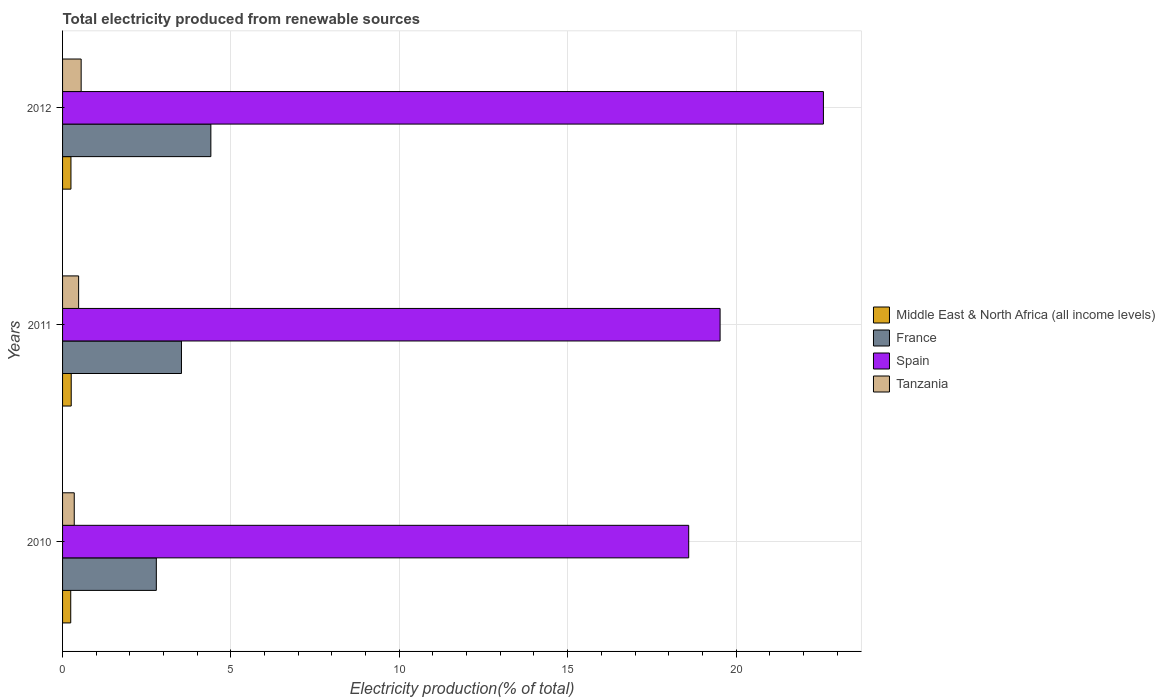How many bars are there on the 1st tick from the top?
Provide a succinct answer. 4. What is the label of the 2nd group of bars from the top?
Give a very brief answer. 2011. In how many cases, is the number of bars for a given year not equal to the number of legend labels?
Give a very brief answer. 0. What is the total electricity produced in Spain in 2011?
Ensure brevity in your answer.  19.53. Across all years, what is the maximum total electricity produced in France?
Your response must be concise. 4.4. Across all years, what is the minimum total electricity produced in Spain?
Offer a terse response. 18.59. What is the total total electricity produced in Middle East & North Africa (all income levels) in the graph?
Your answer should be very brief. 0.75. What is the difference between the total electricity produced in Tanzania in 2010 and that in 2012?
Your answer should be very brief. -0.21. What is the difference between the total electricity produced in Spain in 2010 and the total electricity produced in France in 2011?
Provide a succinct answer. 15.06. What is the average total electricity produced in Tanzania per year?
Make the answer very short. 0.46. In the year 2012, what is the difference between the total electricity produced in Spain and total electricity produced in Middle East & North Africa (all income levels)?
Provide a succinct answer. 22.35. What is the ratio of the total electricity produced in Tanzania in 2010 to that in 2011?
Your response must be concise. 0.73. Is the total electricity produced in Middle East & North Africa (all income levels) in 2010 less than that in 2011?
Keep it short and to the point. Yes. Is the difference between the total electricity produced in Spain in 2011 and 2012 greater than the difference between the total electricity produced in Middle East & North Africa (all income levels) in 2011 and 2012?
Your answer should be very brief. No. What is the difference between the highest and the second highest total electricity produced in Middle East & North Africa (all income levels)?
Offer a terse response. 0.01. What is the difference between the highest and the lowest total electricity produced in Tanzania?
Your response must be concise. 0.21. In how many years, is the total electricity produced in France greater than the average total electricity produced in France taken over all years?
Provide a succinct answer. 1. Is the sum of the total electricity produced in France in 2010 and 2012 greater than the maximum total electricity produced in Middle East & North Africa (all income levels) across all years?
Offer a very short reply. Yes. What does the 2nd bar from the top in 2010 represents?
Offer a terse response. Spain. What does the 3rd bar from the bottom in 2010 represents?
Give a very brief answer. Spain. How many bars are there?
Offer a very short reply. 12. How many years are there in the graph?
Your answer should be compact. 3. Are the values on the major ticks of X-axis written in scientific E-notation?
Offer a very short reply. No. Does the graph contain any zero values?
Provide a succinct answer. No. Where does the legend appear in the graph?
Keep it short and to the point. Center right. What is the title of the graph?
Your response must be concise. Total electricity produced from renewable sources. What is the label or title of the X-axis?
Your answer should be compact. Electricity production(% of total). What is the label or title of the Y-axis?
Offer a terse response. Years. What is the Electricity production(% of total) in Middle East & North Africa (all income levels) in 2010?
Offer a very short reply. 0.24. What is the Electricity production(% of total) of France in 2010?
Your response must be concise. 2.78. What is the Electricity production(% of total) in Spain in 2010?
Offer a very short reply. 18.59. What is the Electricity production(% of total) of Tanzania in 2010?
Offer a terse response. 0.35. What is the Electricity production(% of total) of Middle East & North Africa (all income levels) in 2011?
Offer a terse response. 0.26. What is the Electricity production(% of total) of France in 2011?
Ensure brevity in your answer.  3.53. What is the Electricity production(% of total) in Spain in 2011?
Keep it short and to the point. 19.53. What is the Electricity production(% of total) of Tanzania in 2011?
Offer a very short reply. 0.48. What is the Electricity production(% of total) of Middle East & North Africa (all income levels) in 2012?
Offer a terse response. 0.25. What is the Electricity production(% of total) in France in 2012?
Keep it short and to the point. 4.4. What is the Electricity production(% of total) in Spain in 2012?
Make the answer very short. 22.6. What is the Electricity production(% of total) in Tanzania in 2012?
Offer a terse response. 0.55. Across all years, what is the maximum Electricity production(% of total) in Middle East & North Africa (all income levels)?
Your answer should be compact. 0.26. Across all years, what is the maximum Electricity production(% of total) in France?
Ensure brevity in your answer.  4.4. Across all years, what is the maximum Electricity production(% of total) of Spain?
Your answer should be very brief. 22.6. Across all years, what is the maximum Electricity production(% of total) of Tanzania?
Your answer should be compact. 0.55. Across all years, what is the minimum Electricity production(% of total) of Middle East & North Africa (all income levels)?
Provide a short and direct response. 0.24. Across all years, what is the minimum Electricity production(% of total) in France?
Ensure brevity in your answer.  2.78. Across all years, what is the minimum Electricity production(% of total) in Spain?
Your response must be concise. 18.59. Across all years, what is the minimum Electricity production(% of total) of Tanzania?
Your answer should be compact. 0.35. What is the total Electricity production(% of total) in Middle East & North Africa (all income levels) in the graph?
Your response must be concise. 0.75. What is the total Electricity production(% of total) in France in the graph?
Make the answer very short. 10.72. What is the total Electricity production(% of total) of Spain in the graph?
Make the answer very short. 60.72. What is the total Electricity production(% of total) of Tanzania in the graph?
Your answer should be very brief. 1.38. What is the difference between the Electricity production(% of total) of Middle East & North Africa (all income levels) in 2010 and that in 2011?
Provide a short and direct response. -0.01. What is the difference between the Electricity production(% of total) in France in 2010 and that in 2011?
Offer a very short reply. -0.75. What is the difference between the Electricity production(% of total) in Spain in 2010 and that in 2011?
Make the answer very short. -0.93. What is the difference between the Electricity production(% of total) of Tanzania in 2010 and that in 2011?
Make the answer very short. -0.13. What is the difference between the Electricity production(% of total) of Middle East & North Africa (all income levels) in 2010 and that in 2012?
Your answer should be compact. -0.01. What is the difference between the Electricity production(% of total) in France in 2010 and that in 2012?
Keep it short and to the point. -1.62. What is the difference between the Electricity production(% of total) of Spain in 2010 and that in 2012?
Your answer should be very brief. -4. What is the difference between the Electricity production(% of total) of Tanzania in 2010 and that in 2012?
Your answer should be very brief. -0.21. What is the difference between the Electricity production(% of total) of Middle East & North Africa (all income levels) in 2011 and that in 2012?
Your answer should be compact. 0.01. What is the difference between the Electricity production(% of total) of France in 2011 and that in 2012?
Your response must be concise. -0.87. What is the difference between the Electricity production(% of total) in Spain in 2011 and that in 2012?
Your answer should be very brief. -3.07. What is the difference between the Electricity production(% of total) of Tanzania in 2011 and that in 2012?
Your answer should be compact. -0.08. What is the difference between the Electricity production(% of total) in Middle East & North Africa (all income levels) in 2010 and the Electricity production(% of total) in France in 2011?
Keep it short and to the point. -3.29. What is the difference between the Electricity production(% of total) of Middle East & North Africa (all income levels) in 2010 and the Electricity production(% of total) of Spain in 2011?
Offer a terse response. -19.28. What is the difference between the Electricity production(% of total) of Middle East & North Africa (all income levels) in 2010 and the Electricity production(% of total) of Tanzania in 2011?
Provide a short and direct response. -0.23. What is the difference between the Electricity production(% of total) of France in 2010 and the Electricity production(% of total) of Spain in 2011?
Your answer should be very brief. -16.74. What is the difference between the Electricity production(% of total) in France in 2010 and the Electricity production(% of total) in Tanzania in 2011?
Give a very brief answer. 2.31. What is the difference between the Electricity production(% of total) of Spain in 2010 and the Electricity production(% of total) of Tanzania in 2011?
Offer a very short reply. 18.12. What is the difference between the Electricity production(% of total) in Middle East & North Africa (all income levels) in 2010 and the Electricity production(% of total) in France in 2012?
Provide a short and direct response. -4.16. What is the difference between the Electricity production(% of total) in Middle East & North Africa (all income levels) in 2010 and the Electricity production(% of total) in Spain in 2012?
Keep it short and to the point. -22.35. What is the difference between the Electricity production(% of total) of Middle East & North Africa (all income levels) in 2010 and the Electricity production(% of total) of Tanzania in 2012?
Provide a succinct answer. -0.31. What is the difference between the Electricity production(% of total) of France in 2010 and the Electricity production(% of total) of Spain in 2012?
Make the answer very short. -19.81. What is the difference between the Electricity production(% of total) of France in 2010 and the Electricity production(% of total) of Tanzania in 2012?
Offer a terse response. 2.23. What is the difference between the Electricity production(% of total) of Spain in 2010 and the Electricity production(% of total) of Tanzania in 2012?
Your response must be concise. 18.04. What is the difference between the Electricity production(% of total) in Middle East & North Africa (all income levels) in 2011 and the Electricity production(% of total) in France in 2012?
Your answer should be very brief. -4.15. What is the difference between the Electricity production(% of total) of Middle East & North Africa (all income levels) in 2011 and the Electricity production(% of total) of Spain in 2012?
Make the answer very short. -22.34. What is the difference between the Electricity production(% of total) of Middle East & North Africa (all income levels) in 2011 and the Electricity production(% of total) of Tanzania in 2012?
Offer a terse response. -0.3. What is the difference between the Electricity production(% of total) of France in 2011 and the Electricity production(% of total) of Spain in 2012?
Your answer should be very brief. -19.06. What is the difference between the Electricity production(% of total) in France in 2011 and the Electricity production(% of total) in Tanzania in 2012?
Give a very brief answer. 2.98. What is the difference between the Electricity production(% of total) in Spain in 2011 and the Electricity production(% of total) in Tanzania in 2012?
Keep it short and to the point. 18.97. What is the average Electricity production(% of total) of Middle East & North Africa (all income levels) per year?
Your answer should be very brief. 0.25. What is the average Electricity production(% of total) of France per year?
Offer a terse response. 3.57. What is the average Electricity production(% of total) of Spain per year?
Provide a succinct answer. 20.24. What is the average Electricity production(% of total) of Tanzania per year?
Your response must be concise. 0.46. In the year 2010, what is the difference between the Electricity production(% of total) of Middle East & North Africa (all income levels) and Electricity production(% of total) of France?
Provide a succinct answer. -2.54. In the year 2010, what is the difference between the Electricity production(% of total) of Middle East & North Africa (all income levels) and Electricity production(% of total) of Spain?
Provide a succinct answer. -18.35. In the year 2010, what is the difference between the Electricity production(% of total) in Middle East & North Africa (all income levels) and Electricity production(% of total) in Tanzania?
Your response must be concise. -0.1. In the year 2010, what is the difference between the Electricity production(% of total) of France and Electricity production(% of total) of Spain?
Make the answer very short. -15.81. In the year 2010, what is the difference between the Electricity production(% of total) in France and Electricity production(% of total) in Tanzania?
Keep it short and to the point. 2.44. In the year 2010, what is the difference between the Electricity production(% of total) of Spain and Electricity production(% of total) of Tanzania?
Offer a terse response. 18.25. In the year 2011, what is the difference between the Electricity production(% of total) of Middle East & North Africa (all income levels) and Electricity production(% of total) of France?
Keep it short and to the point. -3.27. In the year 2011, what is the difference between the Electricity production(% of total) in Middle East & North Africa (all income levels) and Electricity production(% of total) in Spain?
Offer a very short reply. -19.27. In the year 2011, what is the difference between the Electricity production(% of total) of Middle East & North Africa (all income levels) and Electricity production(% of total) of Tanzania?
Make the answer very short. -0.22. In the year 2011, what is the difference between the Electricity production(% of total) of France and Electricity production(% of total) of Spain?
Offer a very short reply. -16. In the year 2011, what is the difference between the Electricity production(% of total) in France and Electricity production(% of total) in Tanzania?
Make the answer very short. 3.05. In the year 2011, what is the difference between the Electricity production(% of total) in Spain and Electricity production(% of total) in Tanzania?
Your answer should be very brief. 19.05. In the year 2012, what is the difference between the Electricity production(% of total) of Middle East & North Africa (all income levels) and Electricity production(% of total) of France?
Ensure brevity in your answer.  -4.16. In the year 2012, what is the difference between the Electricity production(% of total) in Middle East & North Africa (all income levels) and Electricity production(% of total) in Spain?
Your answer should be compact. -22.35. In the year 2012, what is the difference between the Electricity production(% of total) in Middle East & North Africa (all income levels) and Electricity production(% of total) in Tanzania?
Offer a terse response. -0.3. In the year 2012, what is the difference between the Electricity production(% of total) of France and Electricity production(% of total) of Spain?
Provide a short and direct response. -18.19. In the year 2012, what is the difference between the Electricity production(% of total) of France and Electricity production(% of total) of Tanzania?
Keep it short and to the point. 3.85. In the year 2012, what is the difference between the Electricity production(% of total) in Spain and Electricity production(% of total) in Tanzania?
Offer a very short reply. 22.04. What is the ratio of the Electricity production(% of total) of Middle East & North Africa (all income levels) in 2010 to that in 2011?
Ensure brevity in your answer.  0.94. What is the ratio of the Electricity production(% of total) of France in 2010 to that in 2011?
Your response must be concise. 0.79. What is the ratio of the Electricity production(% of total) in Spain in 2010 to that in 2011?
Your answer should be very brief. 0.95. What is the ratio of the Electricity production(% of total) of Tanzania in 2010 to that in 2011?
Provide a short and direct response. 0.73. What is the ratio of the Electricity production(% of total) of Middle East & North Africa (all income levels) in 2010 to that in 2012?
Ensure brevity in your answer.  0.98. What is the ratio of the Electricity production(% of total) in France in 2010 to that in 2012?
Offer a terse response. 0.63. What is the ratio of the Electricity production(% of total) in Spain in 2010 to that in 2012?
Your answer should be compact. 0.82. What is the ratio of the Electricity production(% of total) of Tanzania in 2010 to that in 2012?
Give a very brief answer. 0.63. What is the ratio of the Electricity production(% of total) in Middle East & North Africa (all income levels) in 2011 to that in 2012?
Keep it short and to the point. 1.03. What is the ratio of the Electricity production(% of total) in France in 2011 to that in 2012?
Offer a very short reply. 0.8. What is the ratio of the Electricity production(% of total) of Spain in 2011 to that in 2012?
Keep it short and to the point. 0.86. What is the ratio of the Electricity production(% of total) of Tanzania in 2011 to that in 2012?
Give a very brief answer. 0.86. What is the difference between the highest and the second highest Electricity production(% of total) in Middle East & North Africa (all income levels)?
Give a very brief answer. 0.01. What is the difference between the highest and the second highest Electricity production(% of total) in France?
Keep it short and to the point. 0.87. What is the difference between the highest and the second highest Electricity production(% of total) of Spain?
Make the answer very short. 3.07. What is the difference between the highest and the second highest Electricity production(% of total) of Tanzania?
Make the answer very short. 0.08. What is the difference between the highest and the lowest Electricity production(% of total) in Middle East & North Africa (all income levels)?
Your answer should be very brief. 0.01. What is the difference between the highest and the lowest Electricity production(% of total) in France?
Give a very brief answer. 1.62. What is the difference between the highest and the lowest Electricity production(% of total) of Spain?
Provide a succinct answer. 4. What is the difference between the highest and the lowest Electricity production(% of total) in Tanzania?
Provide a succinct answer. 0.21. 